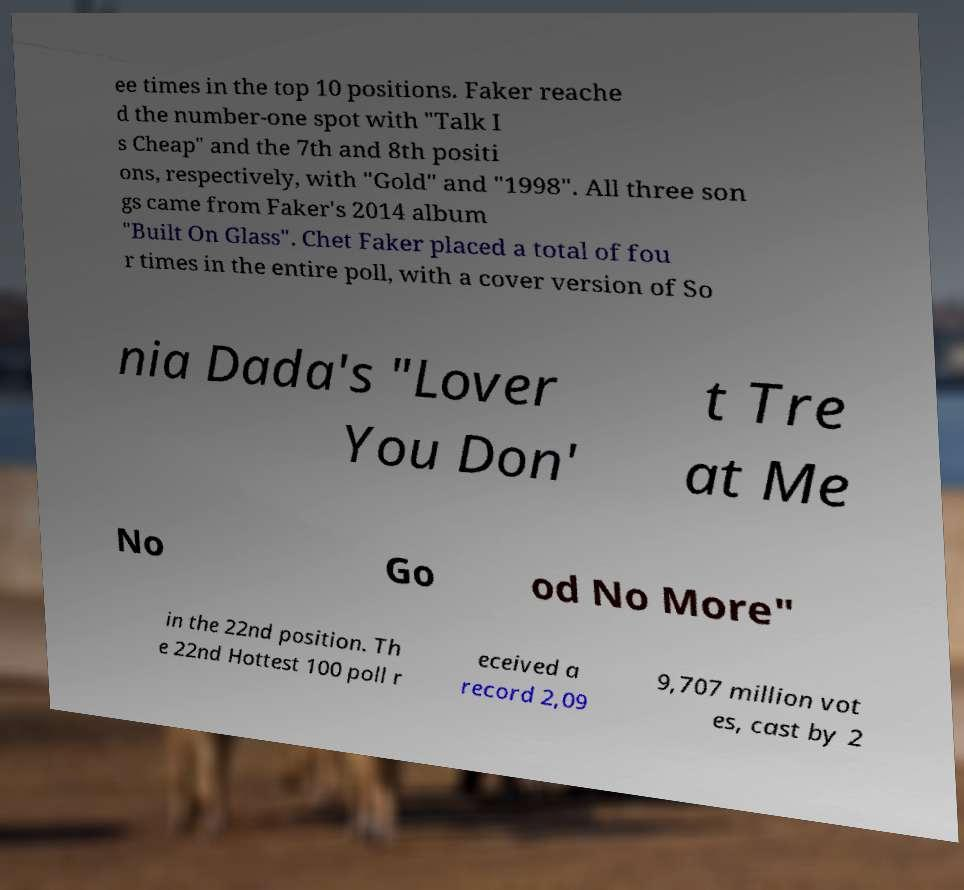Could you extract and type out the text from this image? ee times in the top 10 positions. Faker reache d the number-one spot with "Talk I s Cheap" and the 7th and 8th positi ons, respectively, with "Gold" and "1998". All three son gs came from Faker's 2014 album "Built On Glass". Chet Faker placed a total of fou r times in the entire poll, with a cover version of So nia Dada's "Lover You Don' t Tre at Me No Go od No More" in the 22nd position. Th e 22nd Hottest 100 poll r eceived a record 2,09 9,707 million vot es, cast by 2 